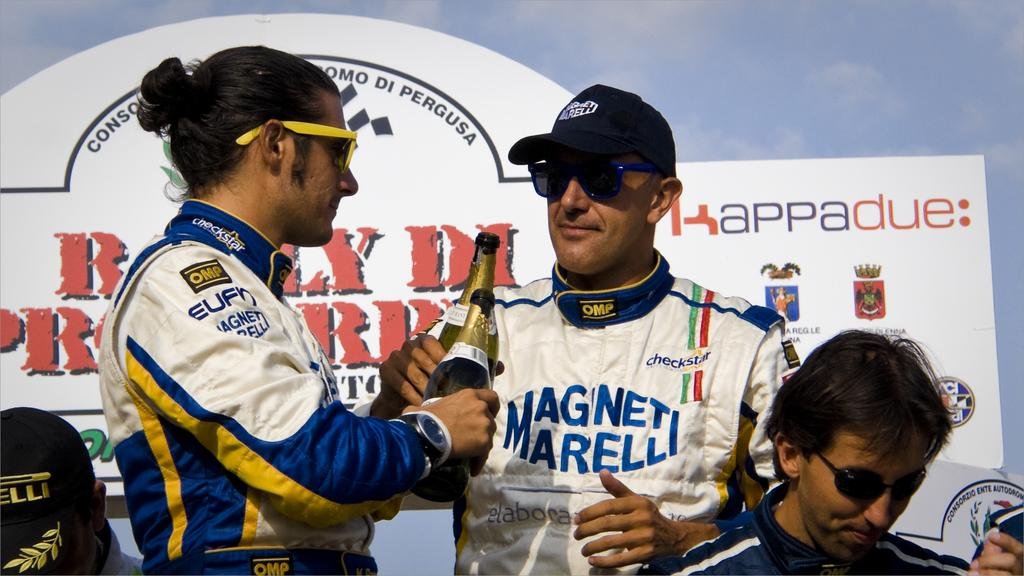Provide a one-sentence caption for the provided image. Two men toasting with bottles of champagne, one of whom is wearing a shirt with Magnet Marelli on it. 